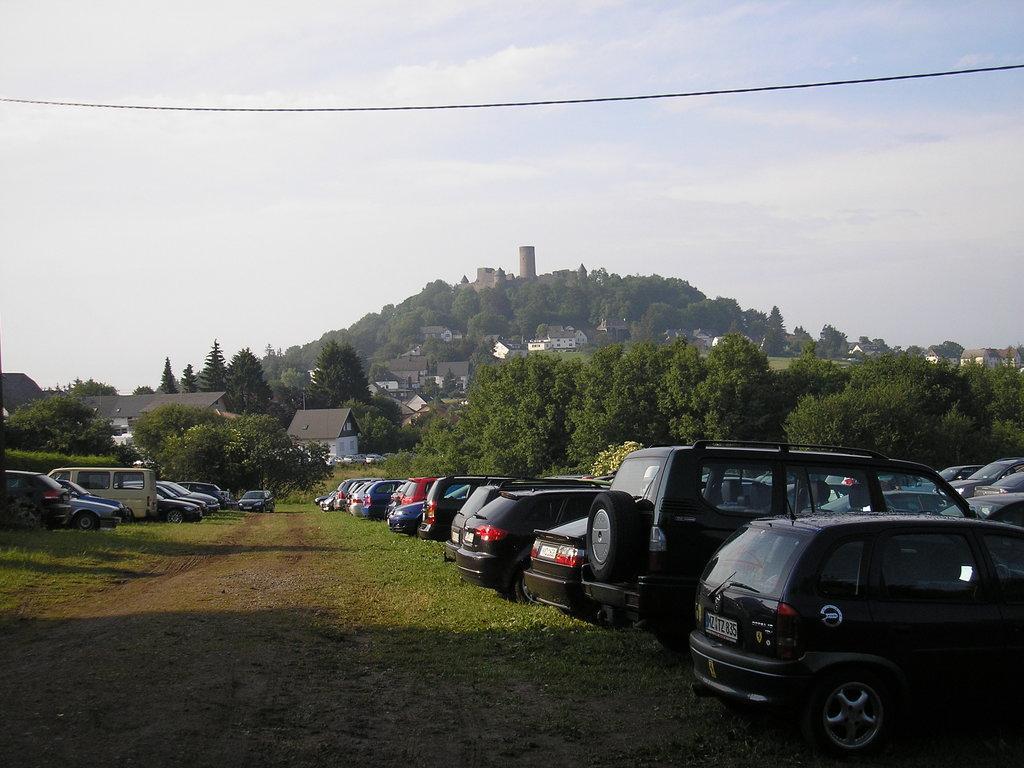How would you summarize this image in a sentence or two? In this image there is a ground on which there are so many cars parked on it. In the background there are trees. At the top there is a hill on which there are so many houses and trees. At the top there is the sky. There is a wire in the air. 